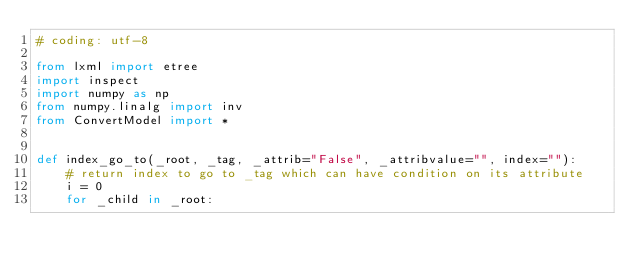Convert code to text. <code><loc_0><loc_0><loc_500><loc_500><_Python_># coding: utf-8

from lxml import etree
import inspect
import numpy as np
from numpy.linalg import inv
from ConvertModel import *


def index_go_to(_root, _tag, _attrib="False", _attribvalue="", index=""):
    # return index to go to _tag which can have condition on its attribute
    i = 0
    for _child in _root:</code> 